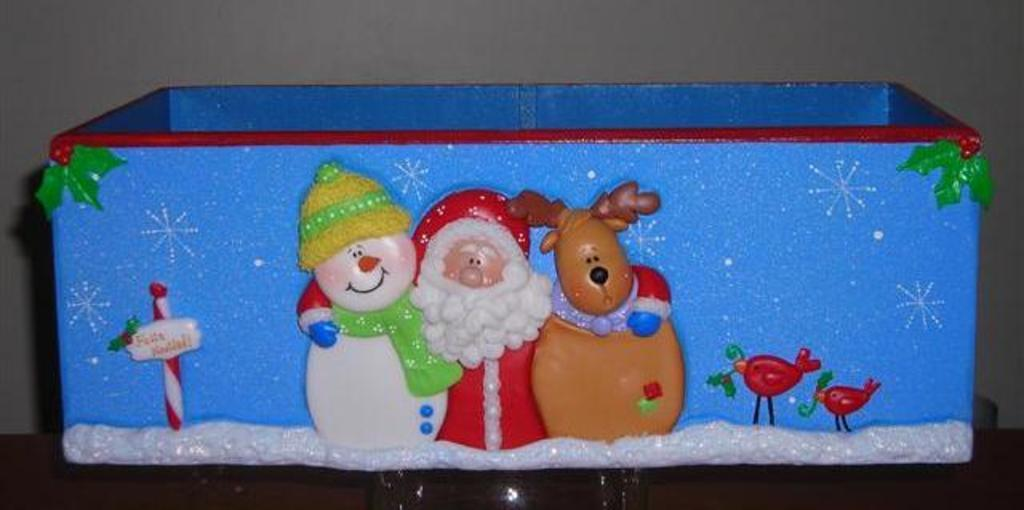What objects are on the blue box in the image? There are toys on a blue box in the image. What can be seen in the background of the image? There is a wall in the background of the image. What type of crayon is being used to draw on the wall in the image? There is no crayon or drawing on the wall in the image. How many umbrellas are visible in the image? There are no umbrellas present in the image. 